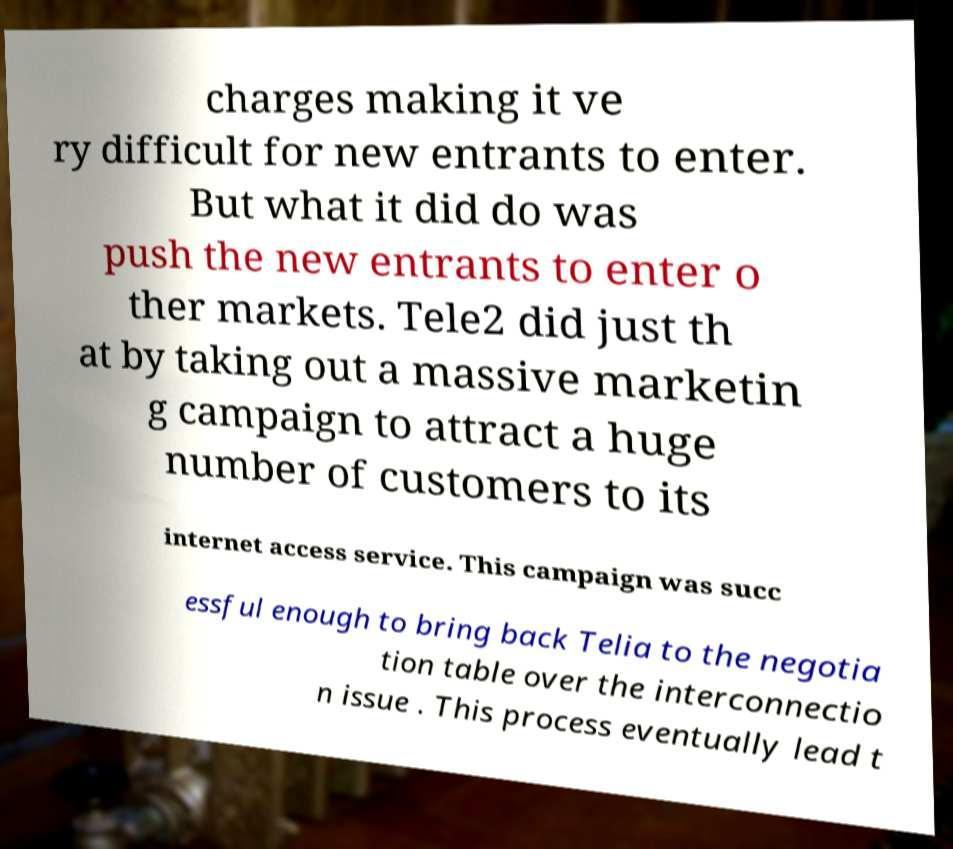I need the written content from this picture converted into text. Can you do that? charges making it ve ry difficult for new entrants to enter. But what it did do was push the new entrants to enter o ther markets. Tele2 did just th at by taking out a massive marketin g campaign to attract a huge number of customers to its internet access service. This campaign was succ essful enough to bring back Telia to the negotia tion table over the interconnectio n issue . This process eventually lead t 